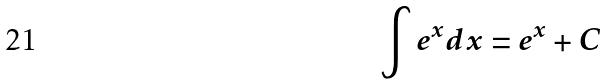Convert formula to latex. <formula><loc_0><loc_0><loc_500><loc_500>\int e ^ { x } d x = e ^ { x } + C</formula> 